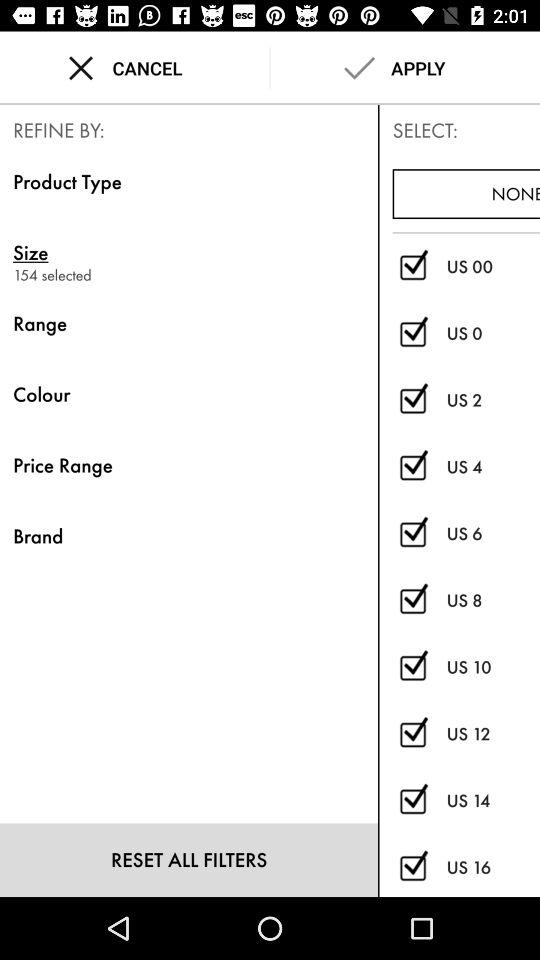What is the number of selected sizes in "REFINE BY"? The number of selected sizes in "REFINE BY" is 154. 